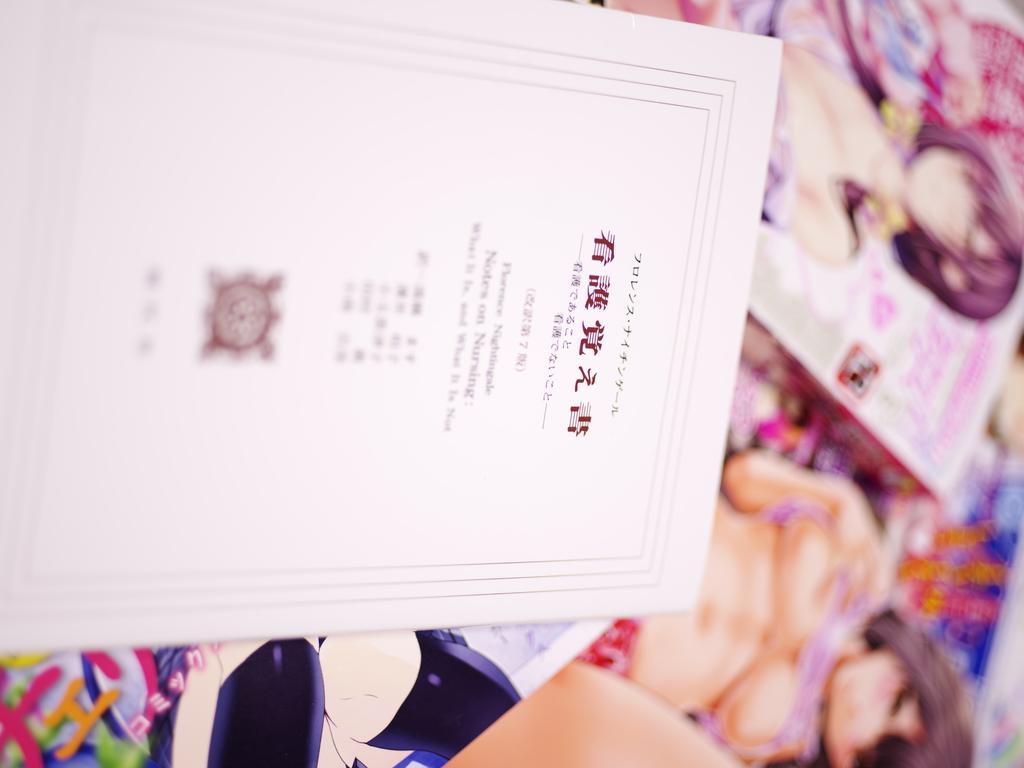In one or two sentences, can you explain what this image depicts? In this image we can see a card and boxes. 